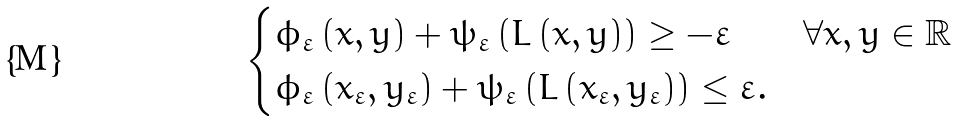<formula> <loc_0><loc_0><loc_500><loc_500>\begin{cases} \phi _ { \varepsilon } \left ( x , y \right ) + \psi _ { \varepsilon } \left ( L \left ( x , y \right ) \right ) \geq - \varepsilon & \forall x , y \in \mathbb { R } \\ \phi _ { \varepsilon } \left ( x _ { \varepsilon } , y _ { \varepsilon } \right ) + \psi _ { \varepsilon } \left ( L \left ( x _ { \varepsilon } , y _ { \varepsilon } \right ) \right ) \leq \varepsilon . \end{cases}</formula> 